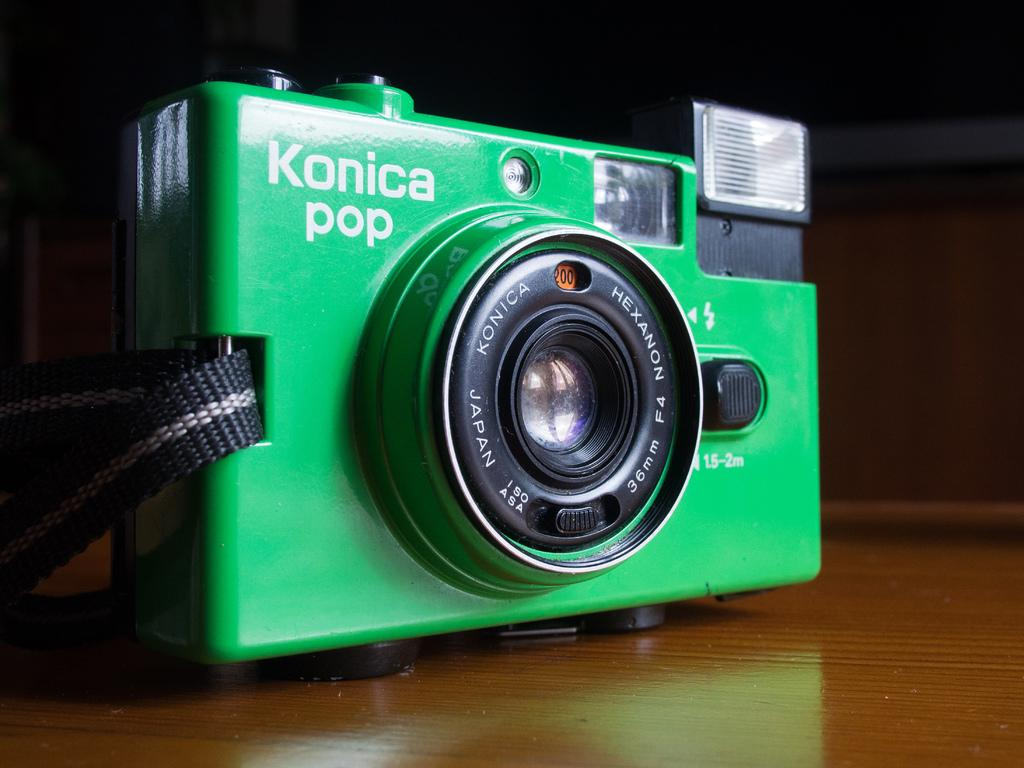What type of camera is in the image? There is a green color camera in the image. What is the camera placed on? The camera is on a wooden surface. Does the camera have any additional features? Yes, the camera has a belt. How would you describe the lighting in the image? The background of the image is dark. Is the governor playing basketball in the image? There is no governor or basketball present in the image. 